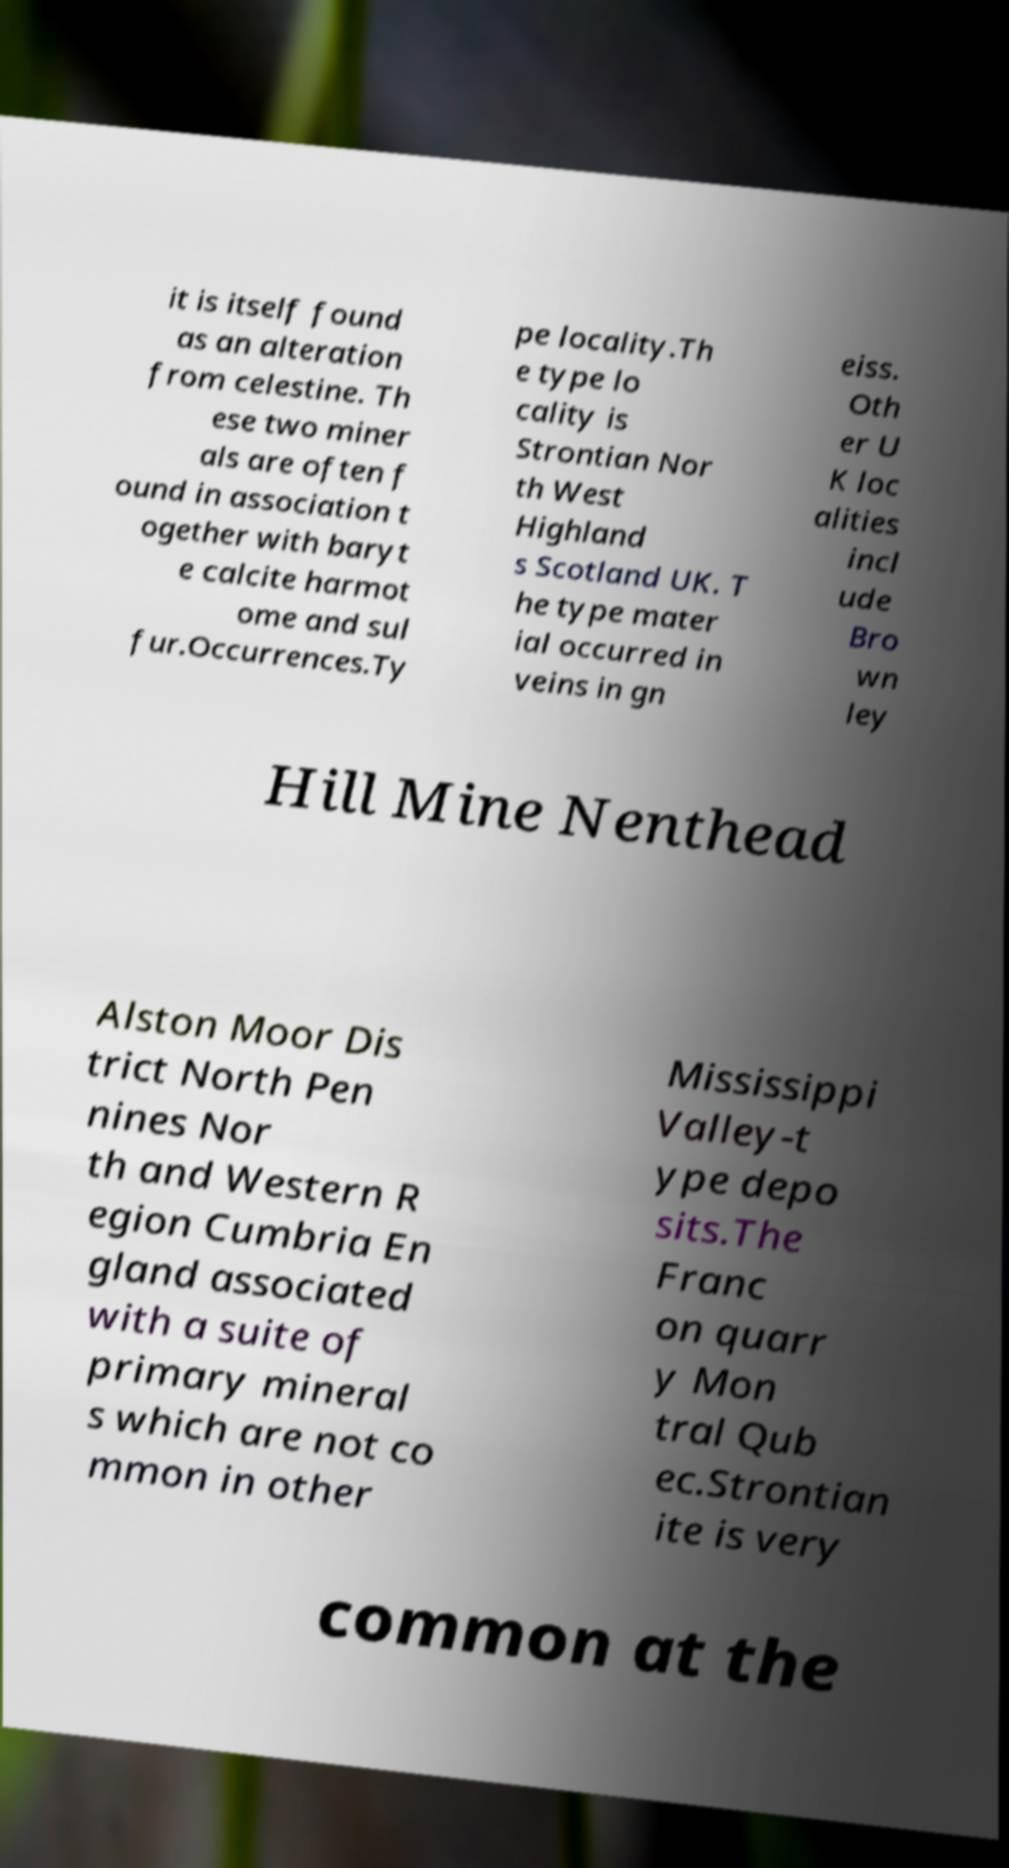I need the written content from this picture converted into text. Can you do that? it is itself found as an alteration from celestine. Th ese two miner als are often f ound in association t ogether with baryt e calcite harmot ome and sul fur.Occurrences.Ty pe locality.Th e type lo cality is Strontian Nor th West Highland s Scotland UK. T he type mater ial occurred in veins in gn eiss. Oth er U K loc alities incl ude Bro wn ley Hill Mine Nenthead Alston Moor Dis trict North Pen nines Nor th and Western R egion Cumbria En gland associated with a suite of primary mineral s which are not co mmon in other Mississippi Valley-t ype depo sits.The Franc on quarr y Mon tral Qub ec.Strontian ite is very common at the 